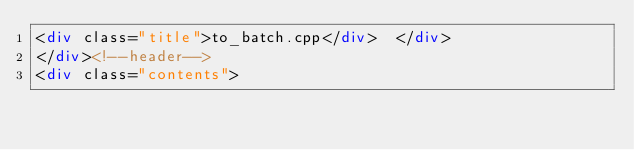Convert code to text. <code><loc_0><loc_0><loc_500><loc_500><_HTML_><div class="title">to_batch.cpp</div>  </div>
</div><!--header-->
<div class="contents"></code> 